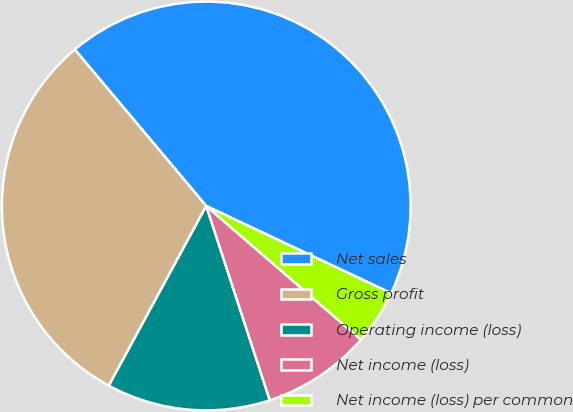Convert chart to OTSL. <chart><loc_0><loc_0><loc_500><loc_500><pie_chart><fcel>Net sales<fcel>Gross profit<fcel>Operating income (loss)<fcel>Net income (loss)<fcel>Net income (loss) per common<nl><fcel>43.14%<fcel>30.97%<fcel>12.94%<fcel>8.63%<fcel>4.32%<nl></chart> 